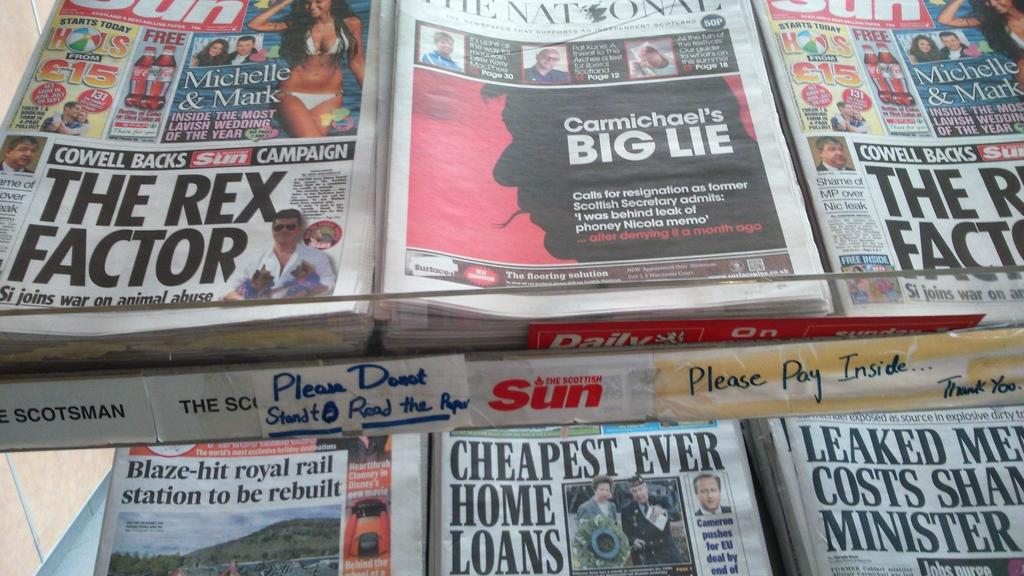What is the title of the main article of the national?
Provide a succinct answer. Carmichael's big lie. What newspapers are pictured?
Keep it short and to the point. Sun. 